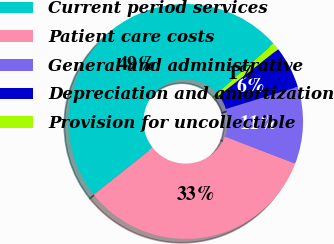<chart> <loc_0><loc_0><loc_500><loc_500><pie_chart><fcel>Current period services<fcel>Patient care costs<fcel>General and administrative<fcel>Depreciation and amortization<fcel>Provision for uncollectible<nl><fcel>49.16%<fcel>33.43%<fcel>10.62%<fcel>5.8%<fcel>0.98%<nl></chart> 